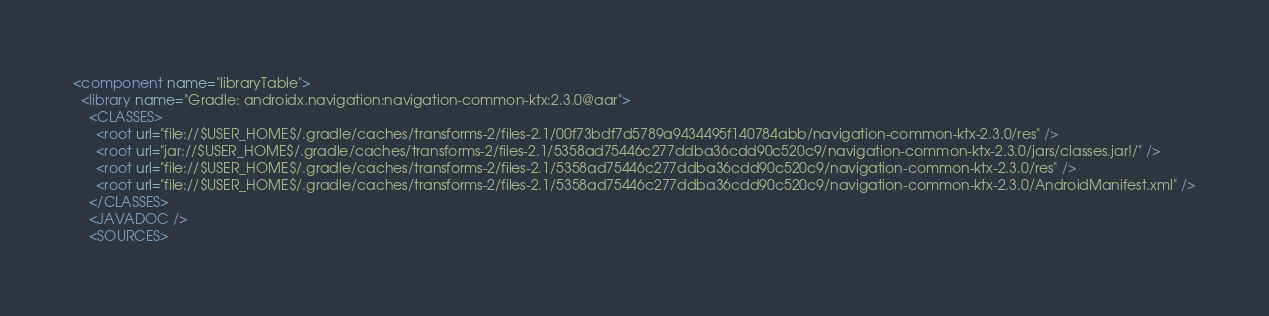<code> <loc_0><loc_0><loc_500><loc_500><_XML_><component name="libraryTable">
  <library name="Gradle: androidx.navigation:navigation-common-ktx:2.3.0@aar">
    <CLASSES>
      <root url="file://$USER_HOME$/.gradle/caches/transforms-2/files-2.1/00f73bdf7d5789a9434495f140784abb/navigation-common-ktx-2.3.0/res" />
      <root url="jar://$USER_HOME$/.gradle/caches/transforms-2/files-2.1/5358ad75446c277ddba36cdd90c520c9/navigation-common-ktx-2.3.0/jars/classes.jar!/" />
      <root url="file://$USER_HOME$/.gradle/caches/transforms-2/files-2.1/5358ad75446c277ddba36cdd90c520c9/navigation-common-ktx-2.3.0/res" />
      <root url="file://$USER_HOME$/.gradle/caches/transforms-2/files-2.1/5358ad75446c277ddba36cdd90c520c9/navigation-common-ktx-2.3.0/AndroidManifest.xml" />
    </CLASSES>
    <JAVADOC />
    <SOURCES></code> 